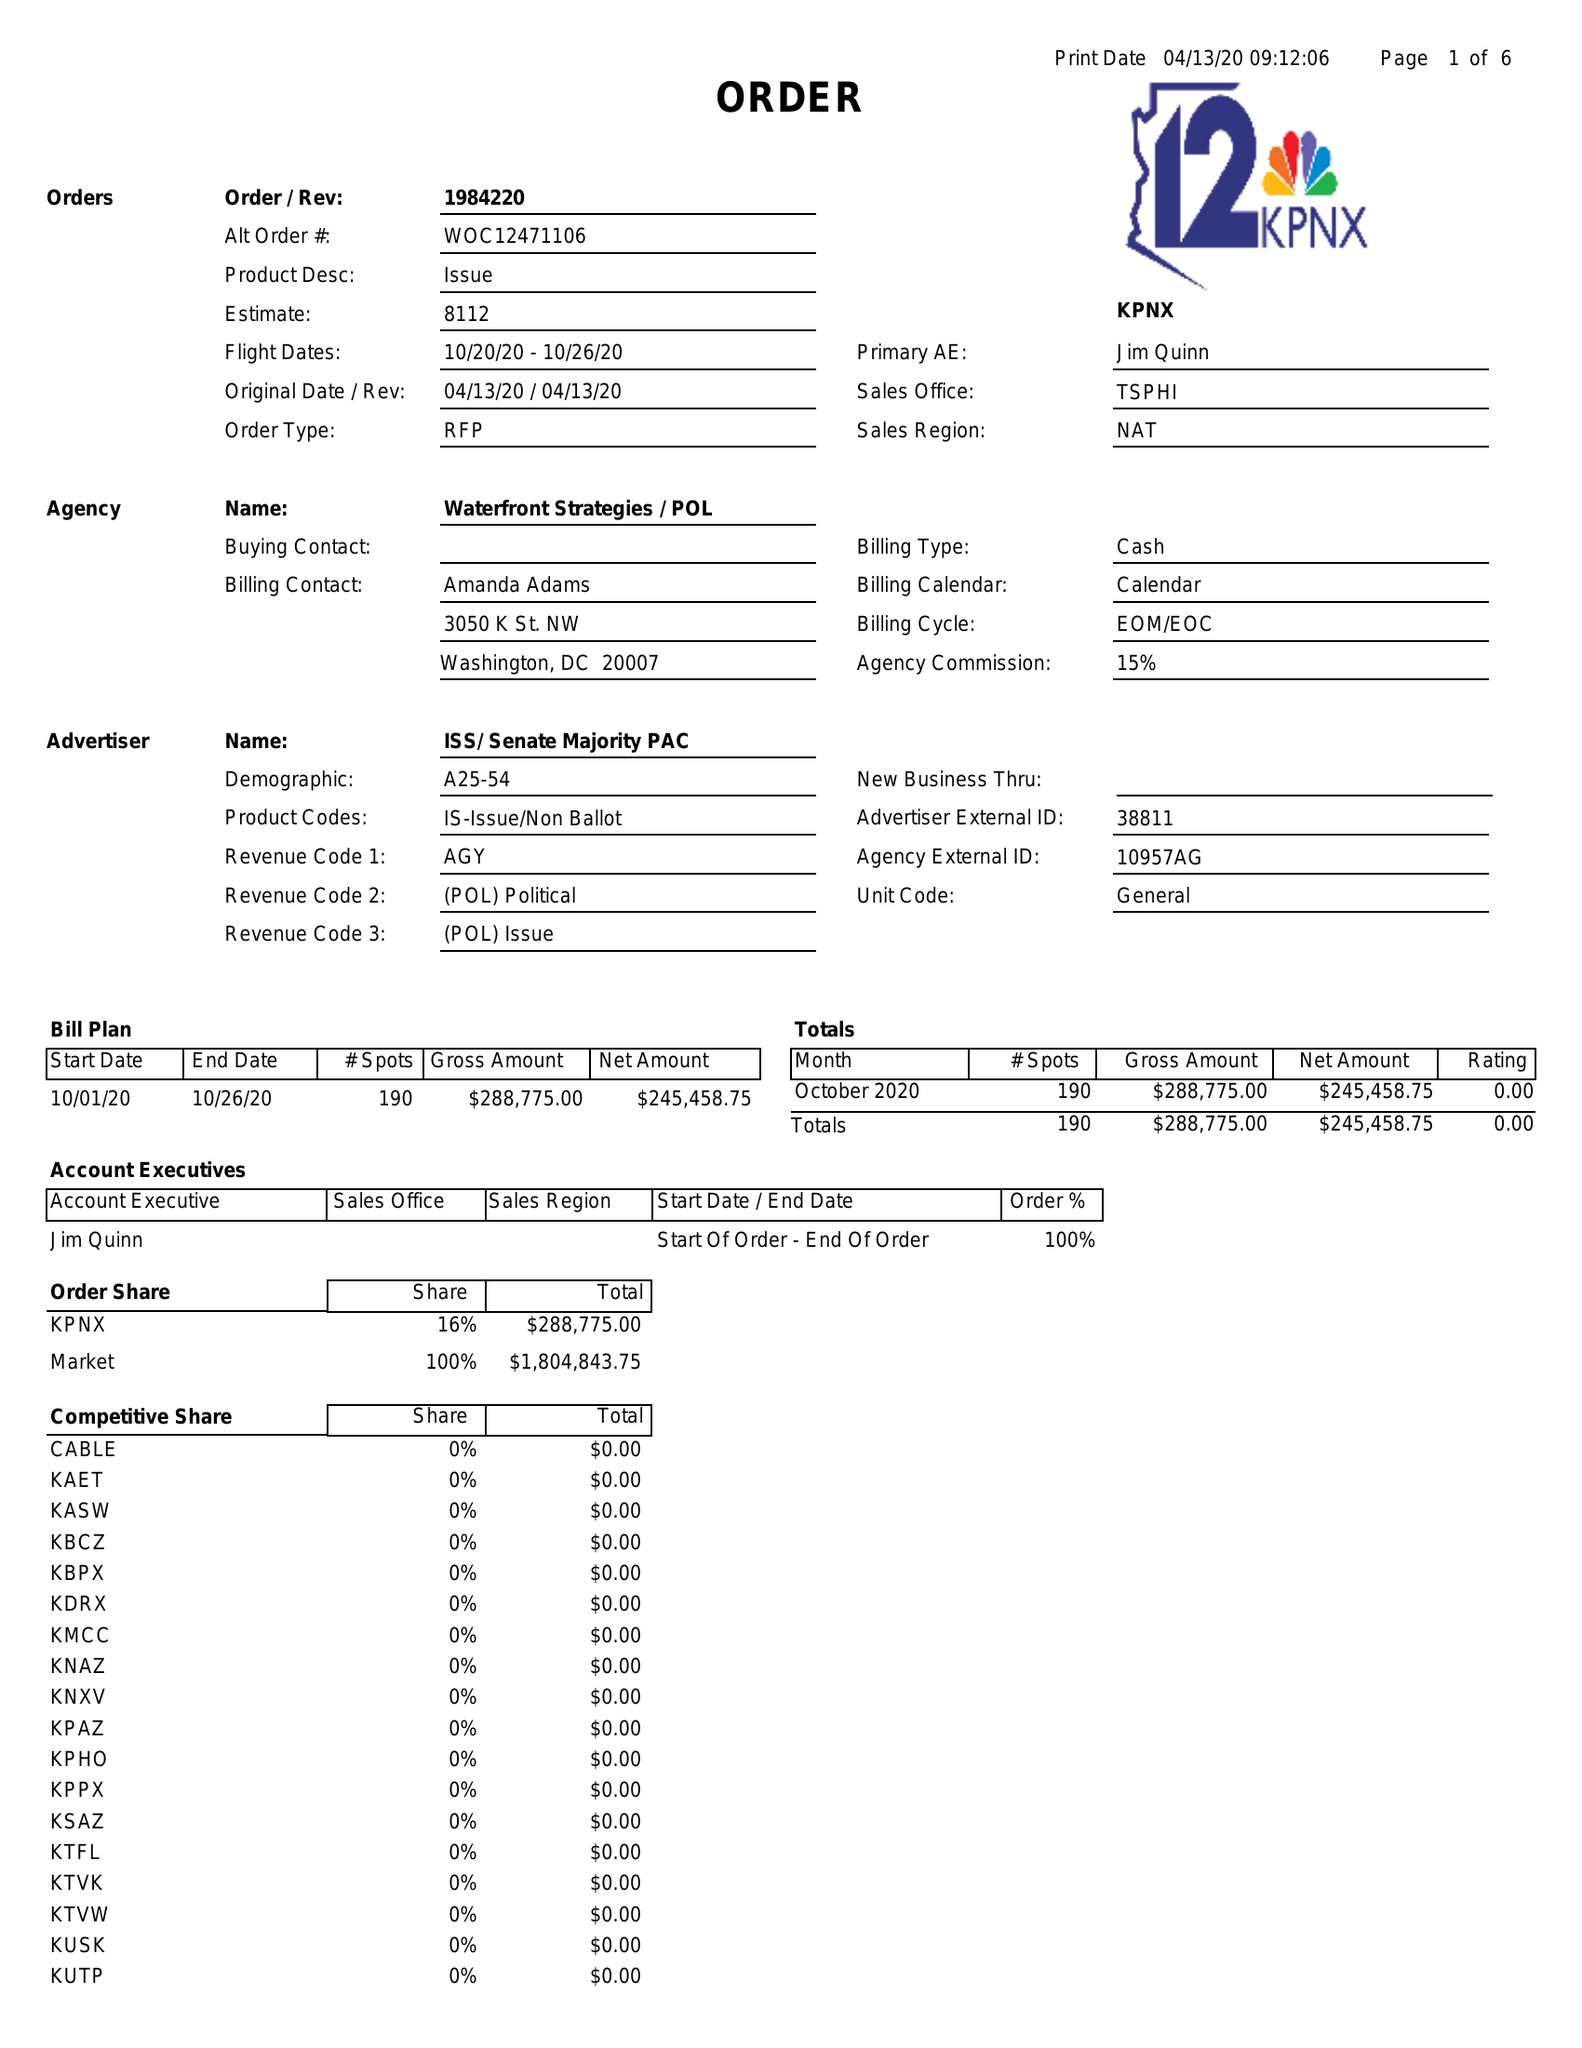What is the value for the flight_from?
Answer the question using a single word or phrase. 10/20/20 